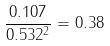<formula> <loc_0><loc_0><loc_500><loc_500>\frac { 0 . 1 0 7 } { 0 . 5 3 2 ^ { 2 } } = 0 . 3 8</formula> 